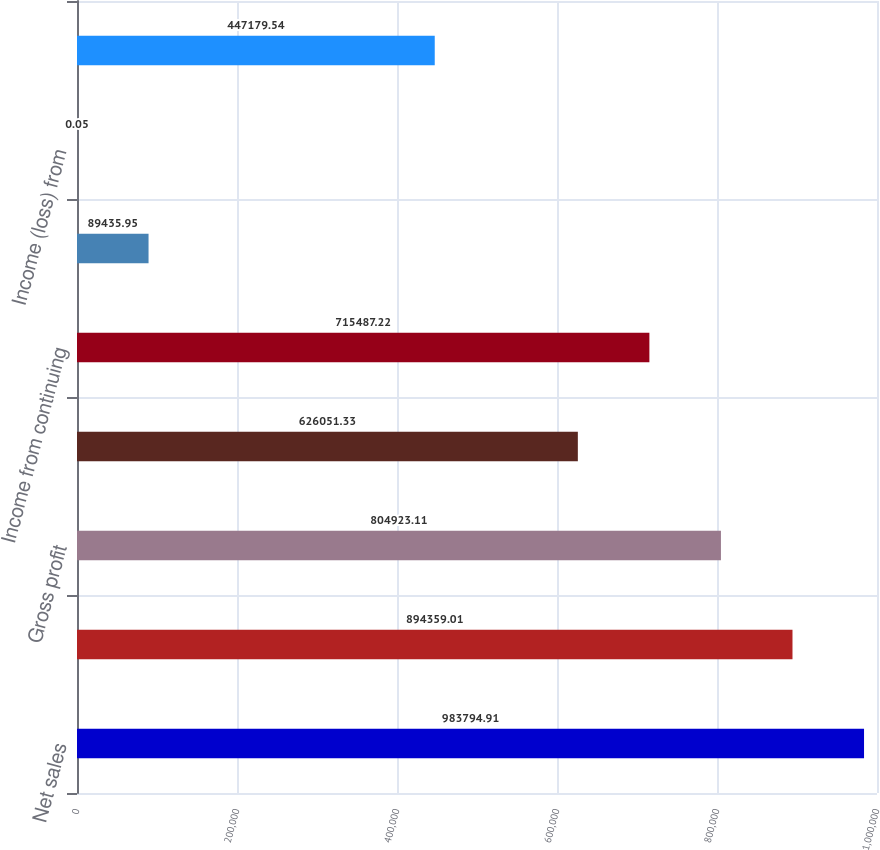Convert chart. <chart><loc_0><loc_0><loc_500><loc_500><bar_chart><fcel>Net sales<fcel>Cost of sales<fcel>Gross profit<fcel>Operating income<fcel>Income from continuing<fcel>Income (loss) from continuing<fcel>Income (loss) from<fcel>Net income (loss)<nl><fcel>983795<fcel>894359<fcel>804923<fcel>626051<fcel>715487<fcel>89435.9<fcel>0.05<fcel>447180<nl></chart> 